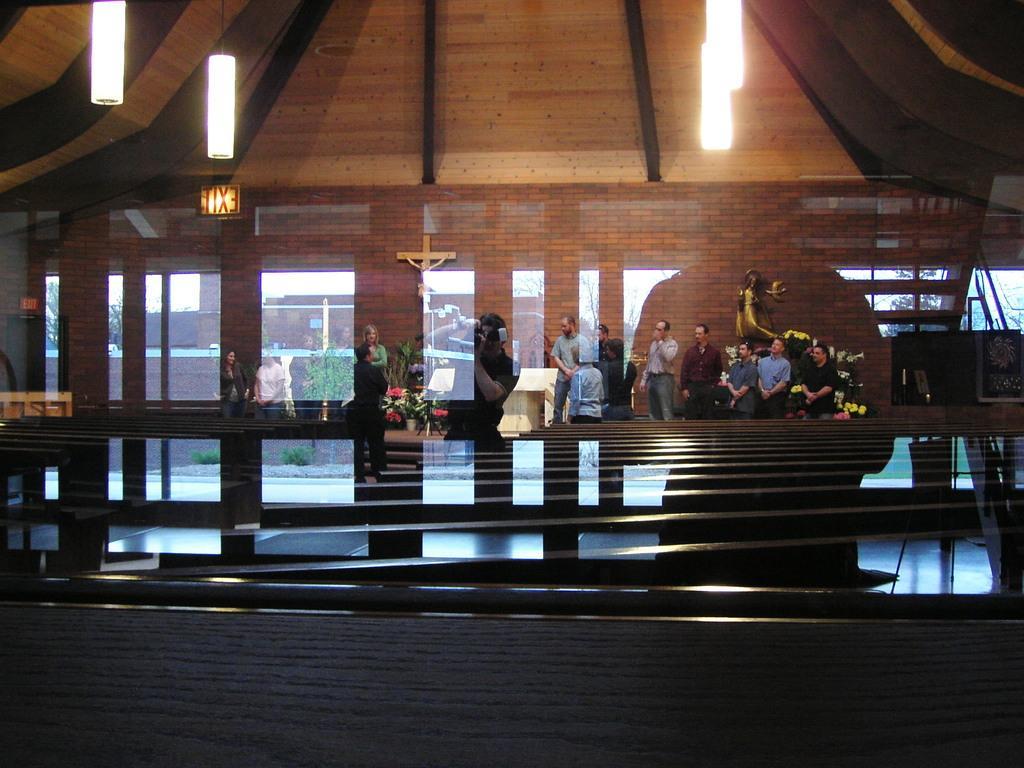Could you give a brief overview of what you see in this image? At the bottom of the image there is a surface. Above the surface there is a glass. Through the glass we can see few people are standing and behind them there is a brick wall and also there are glass doors. There are lights hanging on the top. 